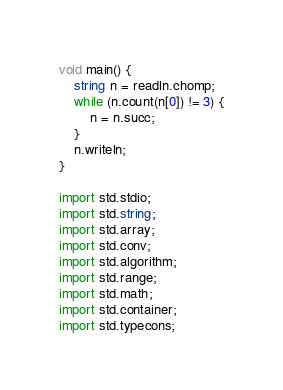<code> <loc_0><loc_0><loc_500><loc_500><_D_>void main() {
    string n = readln.chomp;
    while (n.count(n[0]) != 3) {
        n = n.succ;
    }
    n.writeln;
}

import std.stdio;
import std.string;
import std.array;
import std.conv;
import std.algorithm;
import std.range;
import std.math;
import std.container;
import std.typecons;</code> 